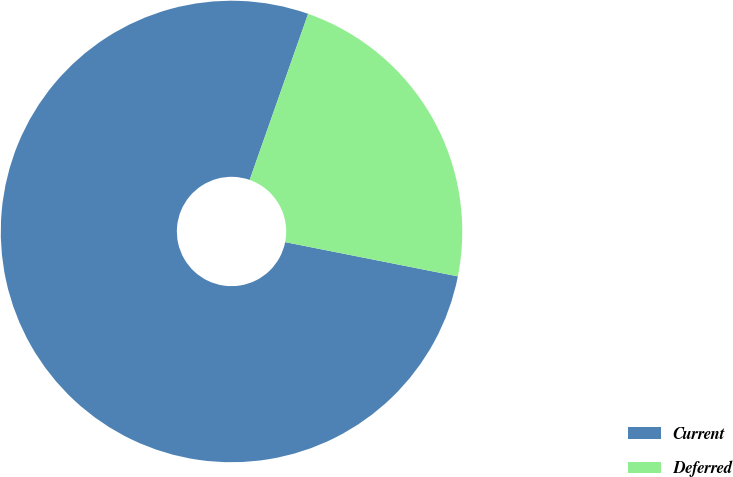Convert chart. <chart><loc_0><loc_0><loc_500><loc_500><pie_chart><fcel>Current<fcel>Deferred<nl><fcel>77.27%<fcel>22.73%<nl></chart> 